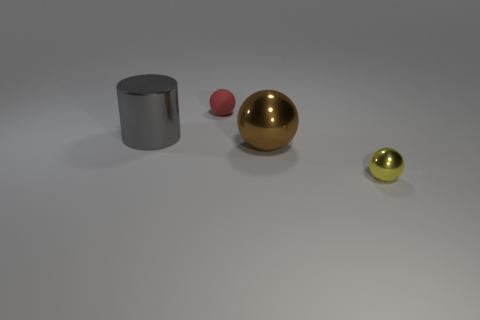The large thing that is made of the same material as the big cylinder is what shape?
Your answer should be compact. Sphere. What is the large thing that is on the left side of the small ball that is on the left side of the tiny yellow metallic thing that is to the right of the cylinder made of?
Offer a very short reply. Metal. How many things are metal spheres behind the tiny yellow sphere or gray rubber cylinders?
Your answer should be compact. 1. What number of other things are there of the same shape as the small red thing?
Your answer should be compact. 2. Are there more tiny rubber things that are on the right side of the yellow ball than yellow spheres?
Your response must be concise. No. What is the size of the other metallic object that is the same shape as the large brown object?
Your response must be concise. Small. Is there any other thing that is the same material as the yellow ball?
Keep it short and to the point. Yes. What shape is the brown thing?
Make the answer very short. Sphere. There is a yellow object that is the same size as the red matte ball; what shape is it?
Ensure brevity in your answer.  Sphere. Is there anything else that is the same color as the metal cylinder?
Give a very brief answer. No. 